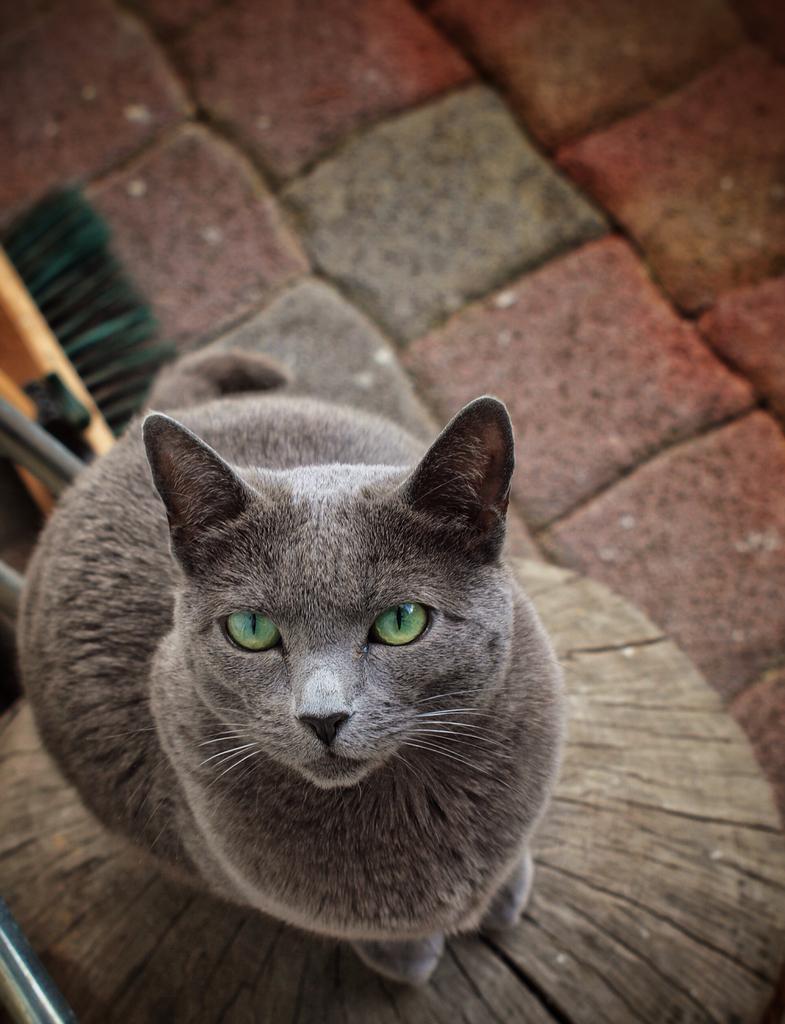How would you summarize this image in a sentence or two? In this image we can see a cat standing on the object and there are some other things on the floor. 